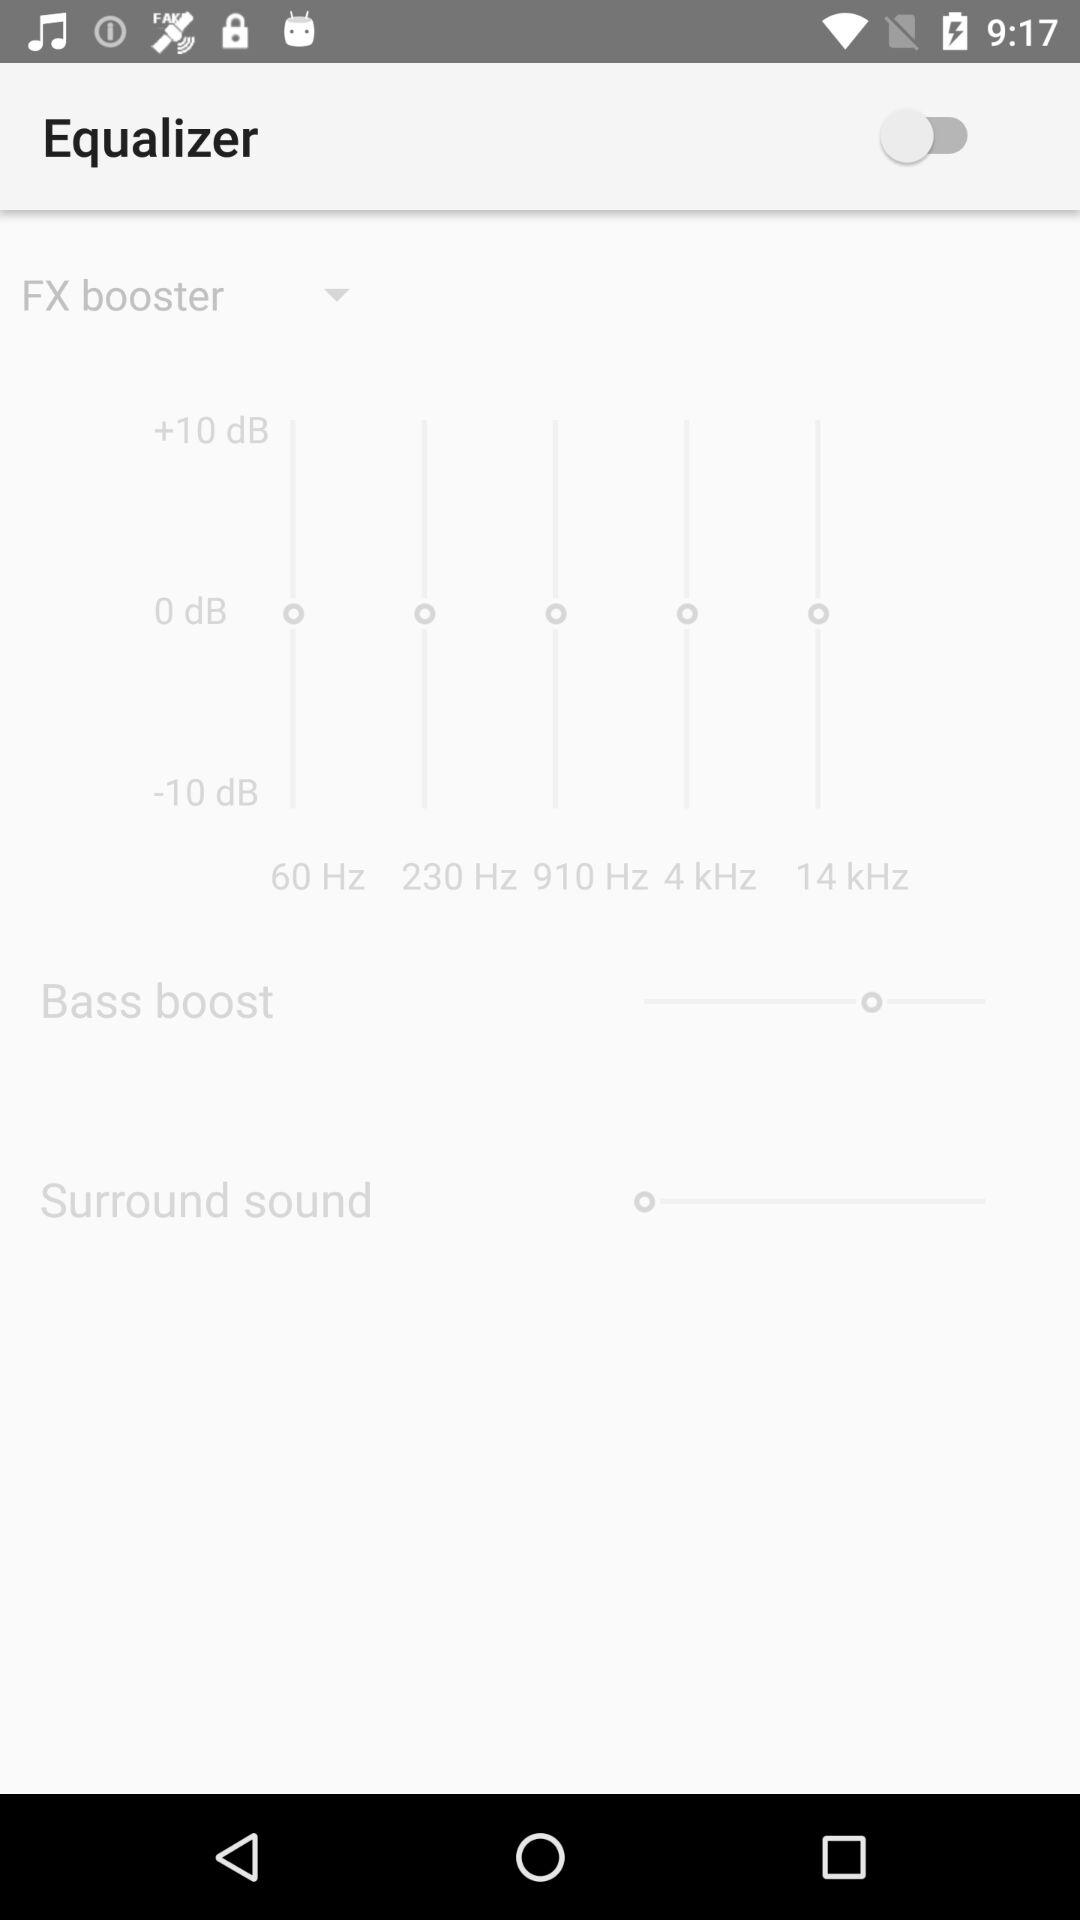What is the status of "Equalizer"? The status is "off". 